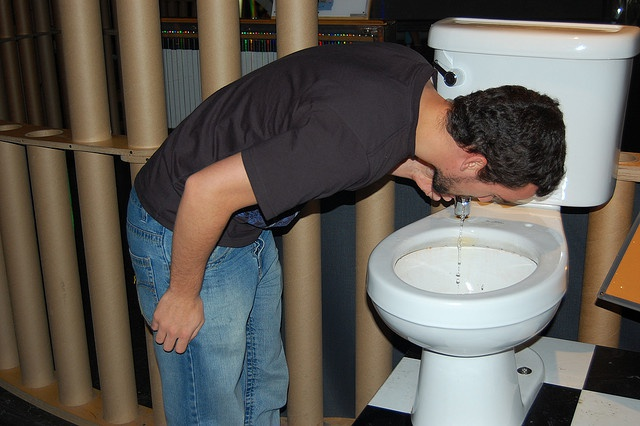Describe the objects in this image and their specific colors. I can see people in black, brown, blue, and gray tones and toilet in black, lightgray, darkgray, and gray tones in this image. 